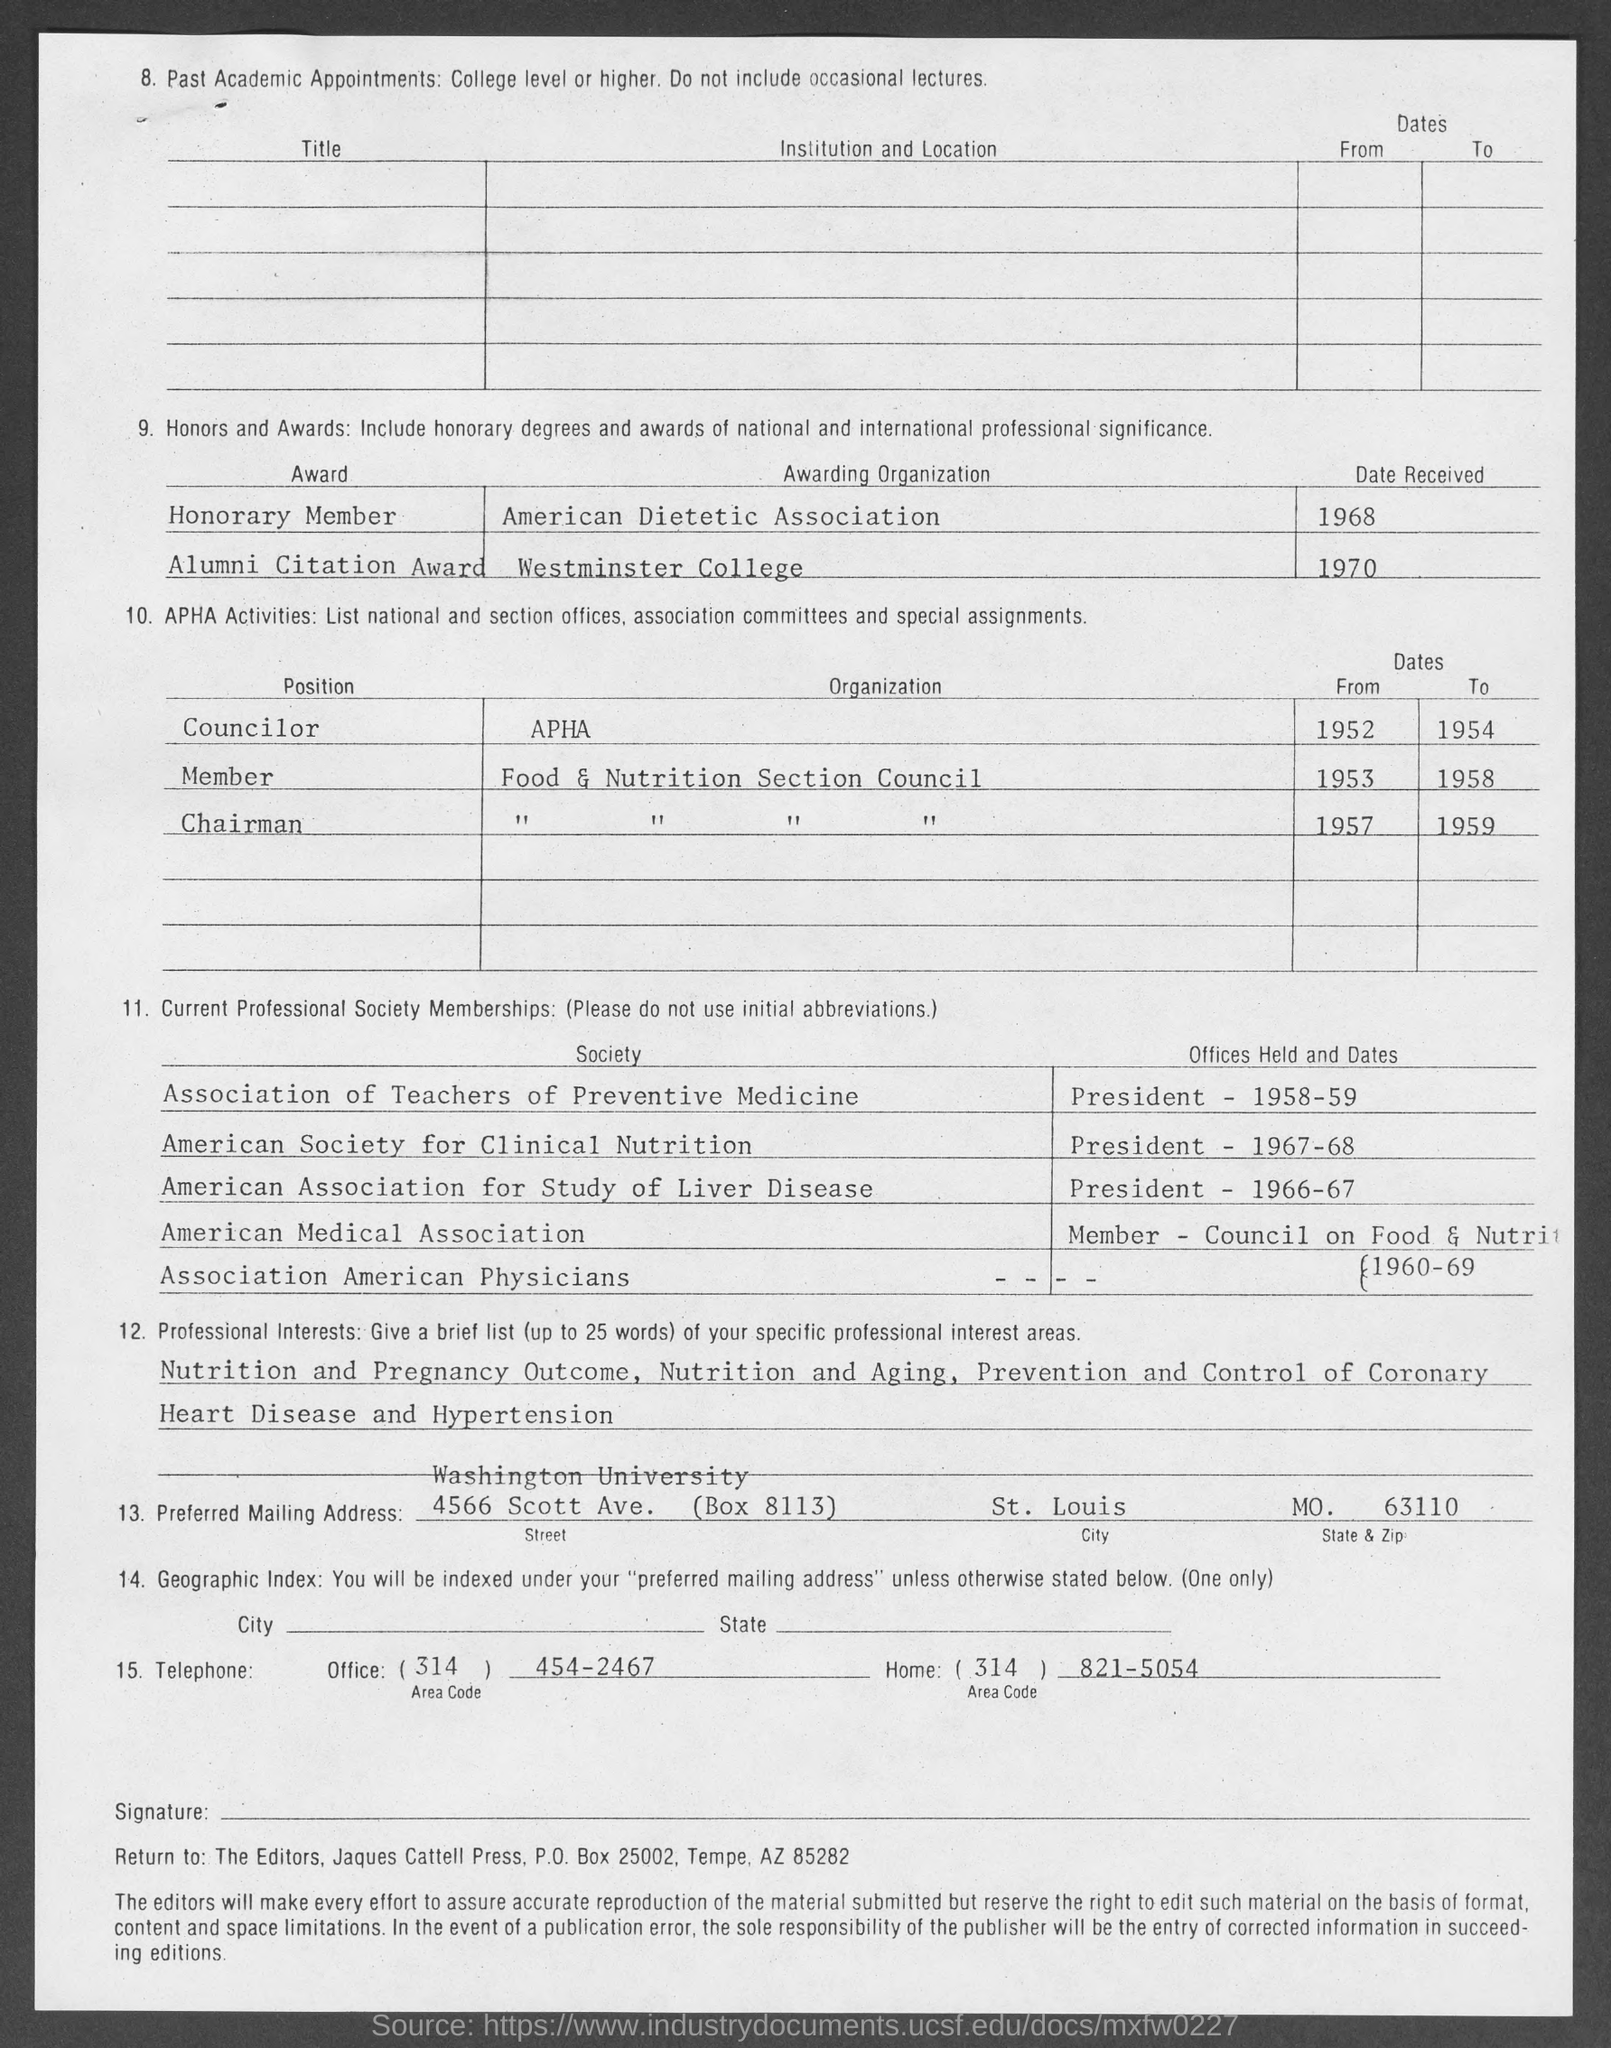what is the office  telephone no.  mentioned in the given page ?
 454-2467 